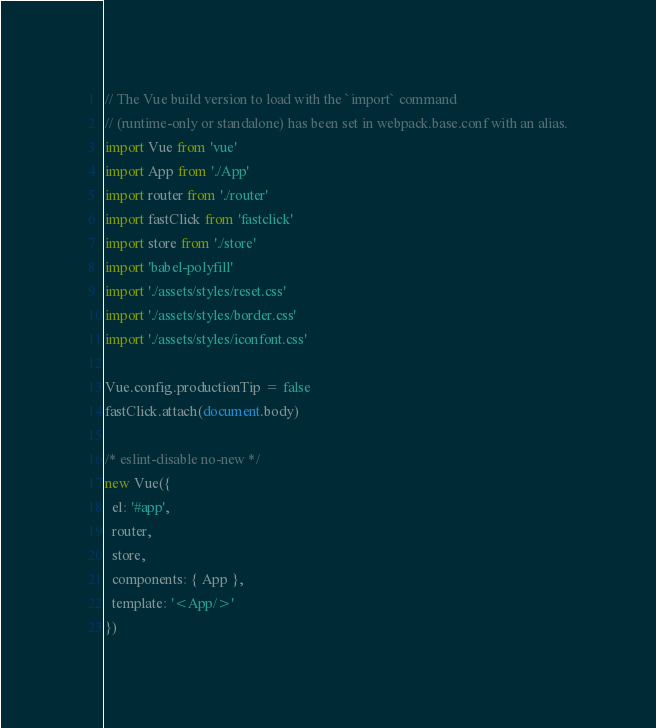<code> <loc_0><loc_0><loc_500><loc_500><_JavaScript_>// The Vue build version to load with the `import` command
// (runtime-only or standalone) has been set in webpack.base.conf with an alias.
import Vue from 'vue'
import App from './App'
import router from './router'
import fastClick from 'fastclick'
import store from './store'
import 'babel-polyfill'
import './assets/styles/reset.css'
import './assets/styles/border.css'
import './assets/styles/iconfont.css'

Vue.config.productionTip = false
fastClick.attach(document.body)

/* eslint-disable no-new */
new Vue({
  el: '#app',
  router,
  store,
  components: { App },
  template: '<App/>'
})
</code> 